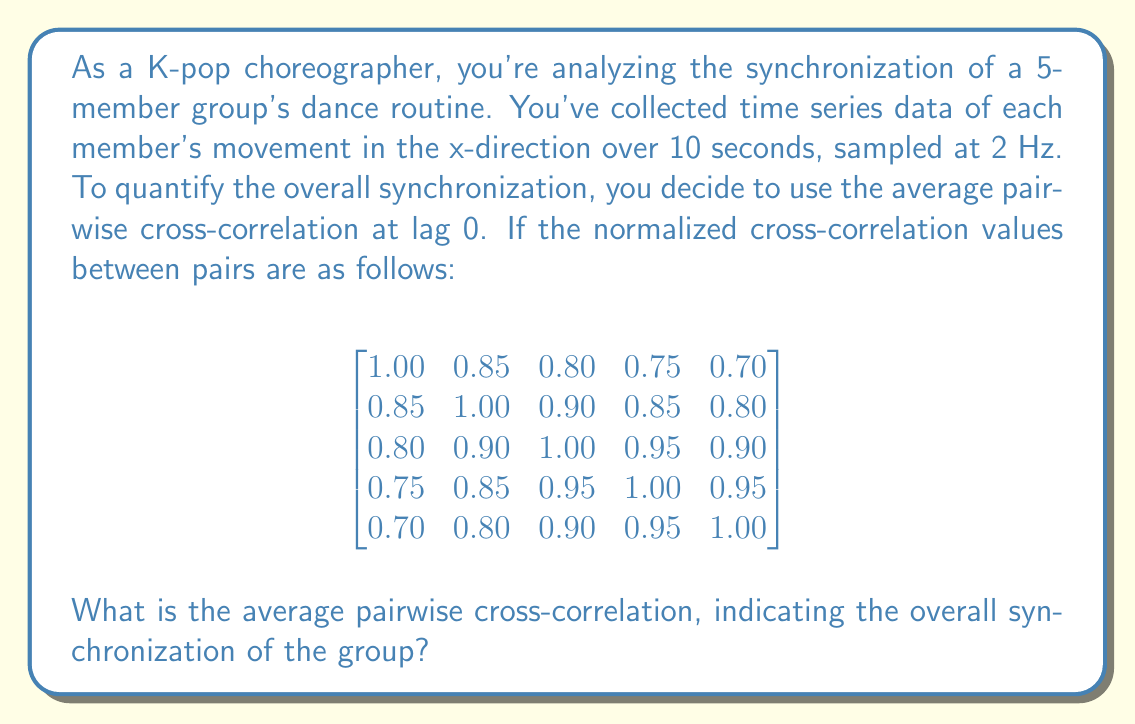Can you solve this math problem? To solve this problem, we need to follow these steps:

1) First, note that the matrix given is symmetric, as cross-correlation between member A and B is the same as between B and A.

2) We need to sum all the unique pairwise correlations. This means we only need to consider the upper (or lower) triangular part of the matrix, excluding the diagonal (which are all 1.00, representing each member's correlation with themselves).

3) The unique pairs are:
   (1,2): 0.85, (1,3): 0.80, (1,4): 0.75, (1,5): 0.70
   (2,3): 0.90, (2,4): 0.85, (2,5): 0.80
   (3,4): 0.95, (3,5): 0.90
   (4,5): 0.95

4) Sum these values:
   $$ 0.85 + 0.80 + 0.75 + 0.70 + 0.90 + 0.85 + 0.80 + 0.95 + 0.90 + 0.95 = 8.45 $$

5) Count the number of unique pairs. For 5 members, this is:
   $$ \frac{5 * (5-1)}{2} = 10 $$

6) Calculate the average by dividing the sum by the number of pairs:
   $$ \frac{8.45}{10} = 0.845 $$

Therefore, the average pairwise cross-correlation is 0.845.
Answer: 0.845 